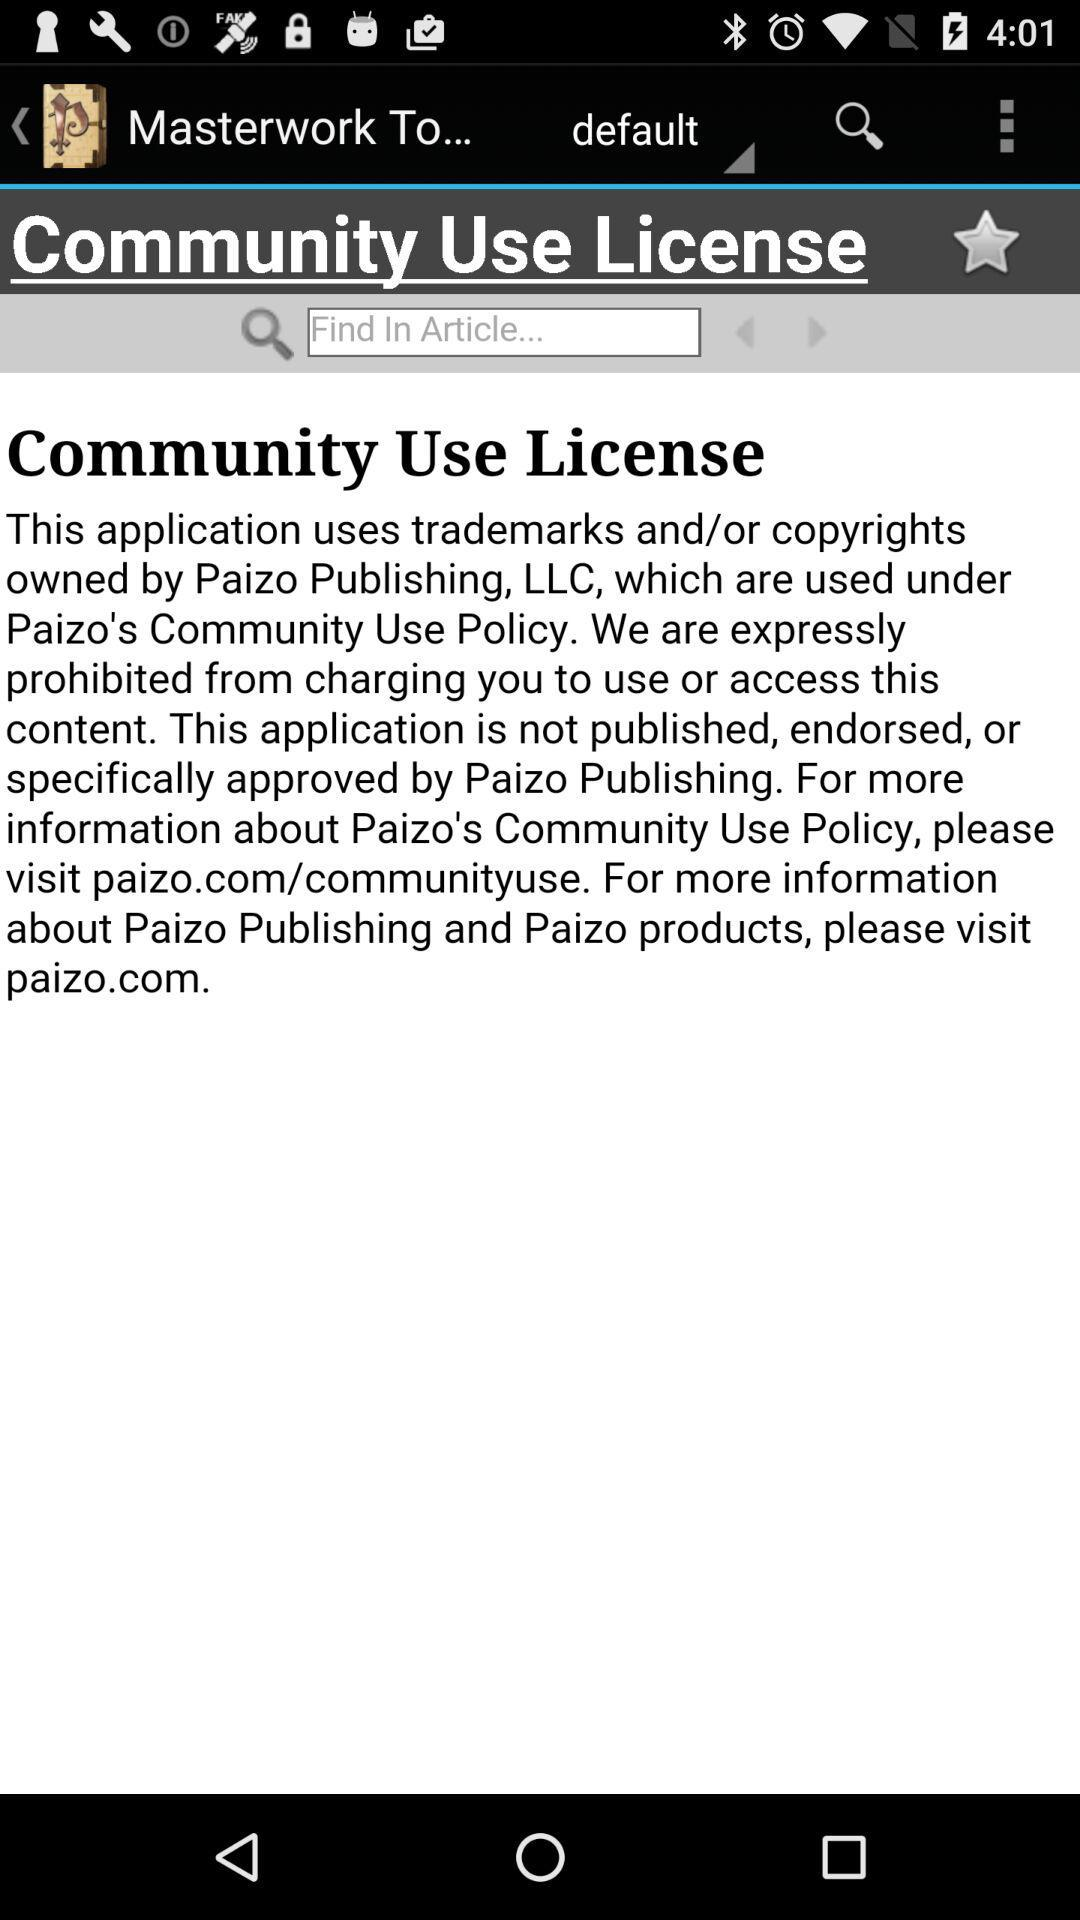What application uses trademarks and/or copyrights owned by "Paizo Publishing"? The application that uses trademarks and/or copyrights owned by "Paizo Publishing" is "Masterwork Tools: Pathfinder Open Reference". 